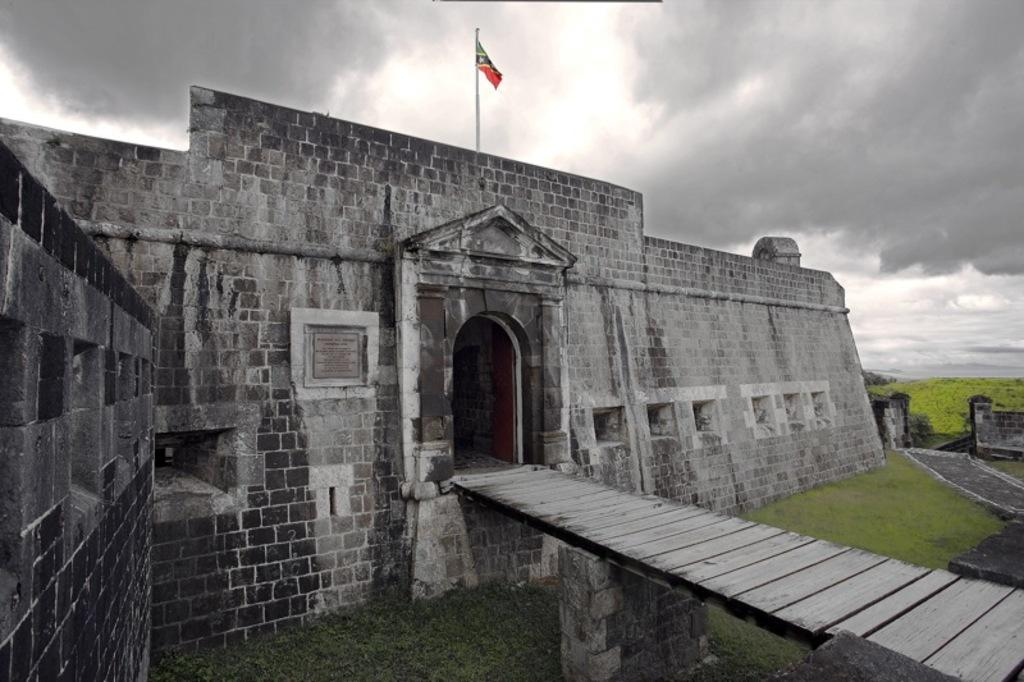What type of structure can be seen in the image? There is a fence wall in the image. What is located above the fence wall? There is a flag above the fence wall. Where is the bridge situated in the image? The bridge is in the right corner of the image. What can be seen below the bridge? There is a greenery ground below the bridge. How would you describe the sky in the image? The sky is cloudy in the image. Can you tell me what type of joke is being told by the stove in the image? There is no stove present in the image, so it is not possible to determine if a joke is being told or not. 